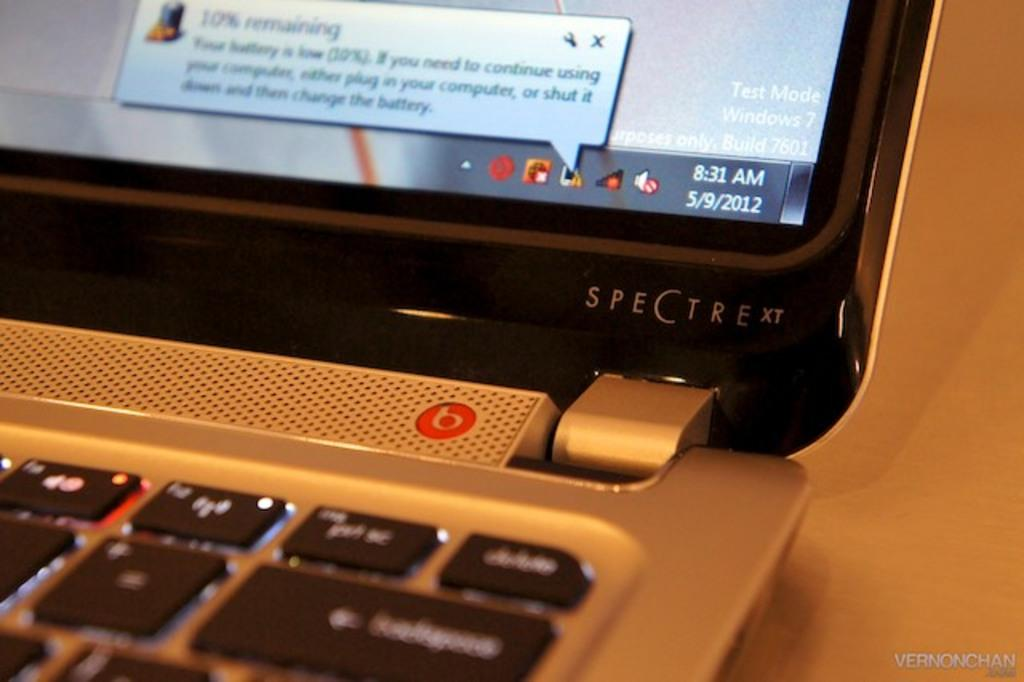<image>
Present a compact description of the photo's key features. A Spectra xt computer is open and turned on. 